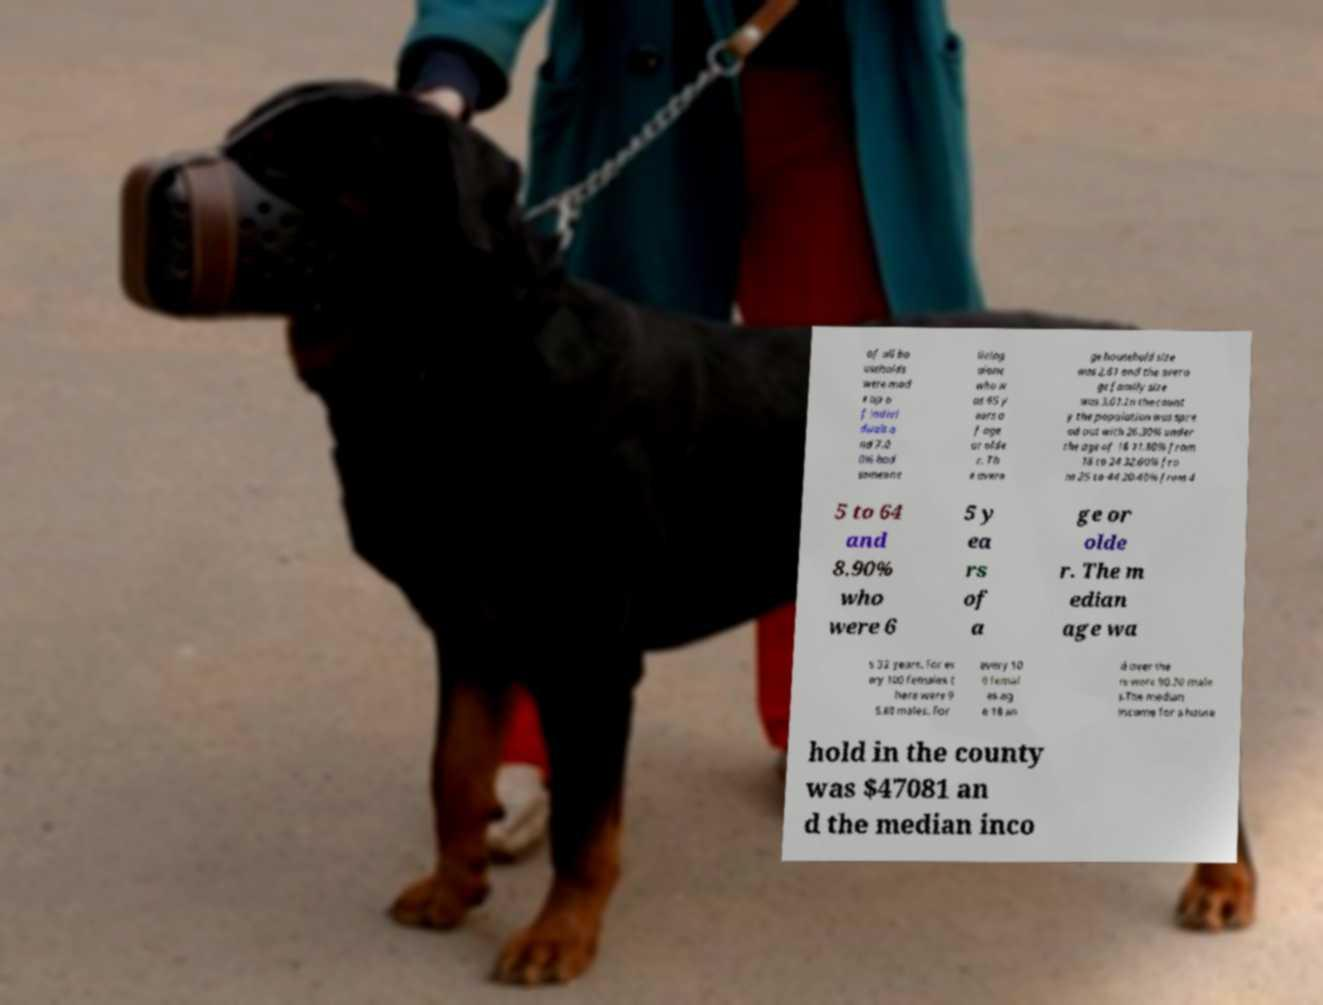I need the written content from this picture converted into text. Can you do that? of all ho useholds were mad e up o f indivi duals a nd 7.0 0% had someone living alone who w as 65 y ears o f age or olde r. Th e avera ge household size was 2.61 and the avera ge family size was 3.01.In the count y the population was spre ad out with 26.30% under the age of 18 11.80% from 18 to 24 32.60% fro m 25 to 44 20.40% from 4 5 to 64 and 8.90% who were 6 5 y ea rs of a ge or olde r. The m edian age wa s 32 years. For ev ery 100 females t here were 9 5.80 males. For every 10 0 femal es ag e 18 an d over the re were 90.70 male s.The median income for a house hold in the county was $47081 an d the median inco 